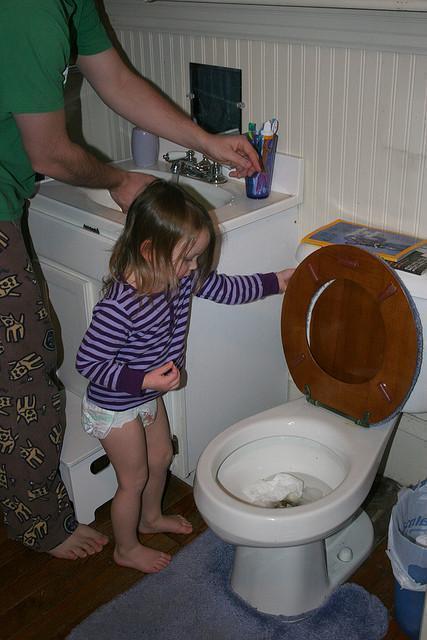What is the toddler about to do?
Select the accurate answer and provide explanation: 'Answer: answer
Rationale: rationale.'
Options: Flush toilet, poo, throw up, pee. Answer: flush toilet.
Rationale: They are going to flush the toilet after going to the bathroom. 